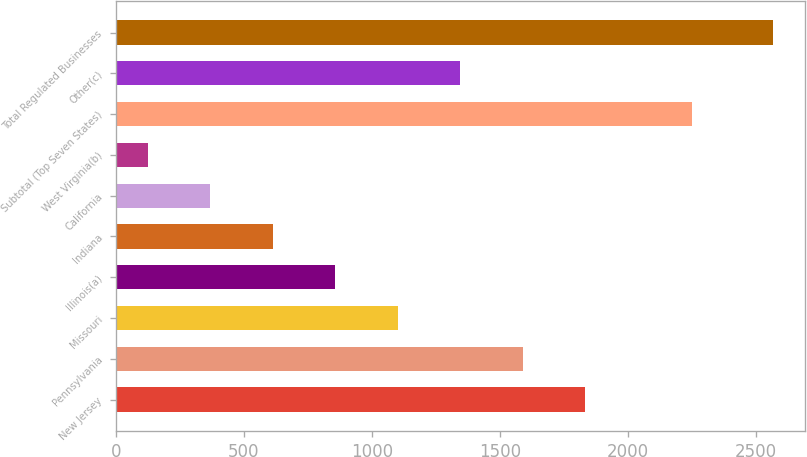Convert chart. <chart><loc_0><loc_0><loc_500><loc_500><bar_chart><fcel>New Jersey<fcel>Pennsylvania<fcel>Missouri<fcel>Illinois(a)<fcel>Indiana<fcel>California<fcel>West Virginia(b)<fcel>Subtotal (Top Seven States)<fcel>Other(c)<fcel>Total Regulated Businesses<nl><fcel>1832.58<fcel>1588.64<fcel>1100.76<fcel>856.82<fcel>612.88<fcel>368.94<fcel>125<fcel>2249.6<fcel>1344.7<fcel>2564.4<nl></chart> 